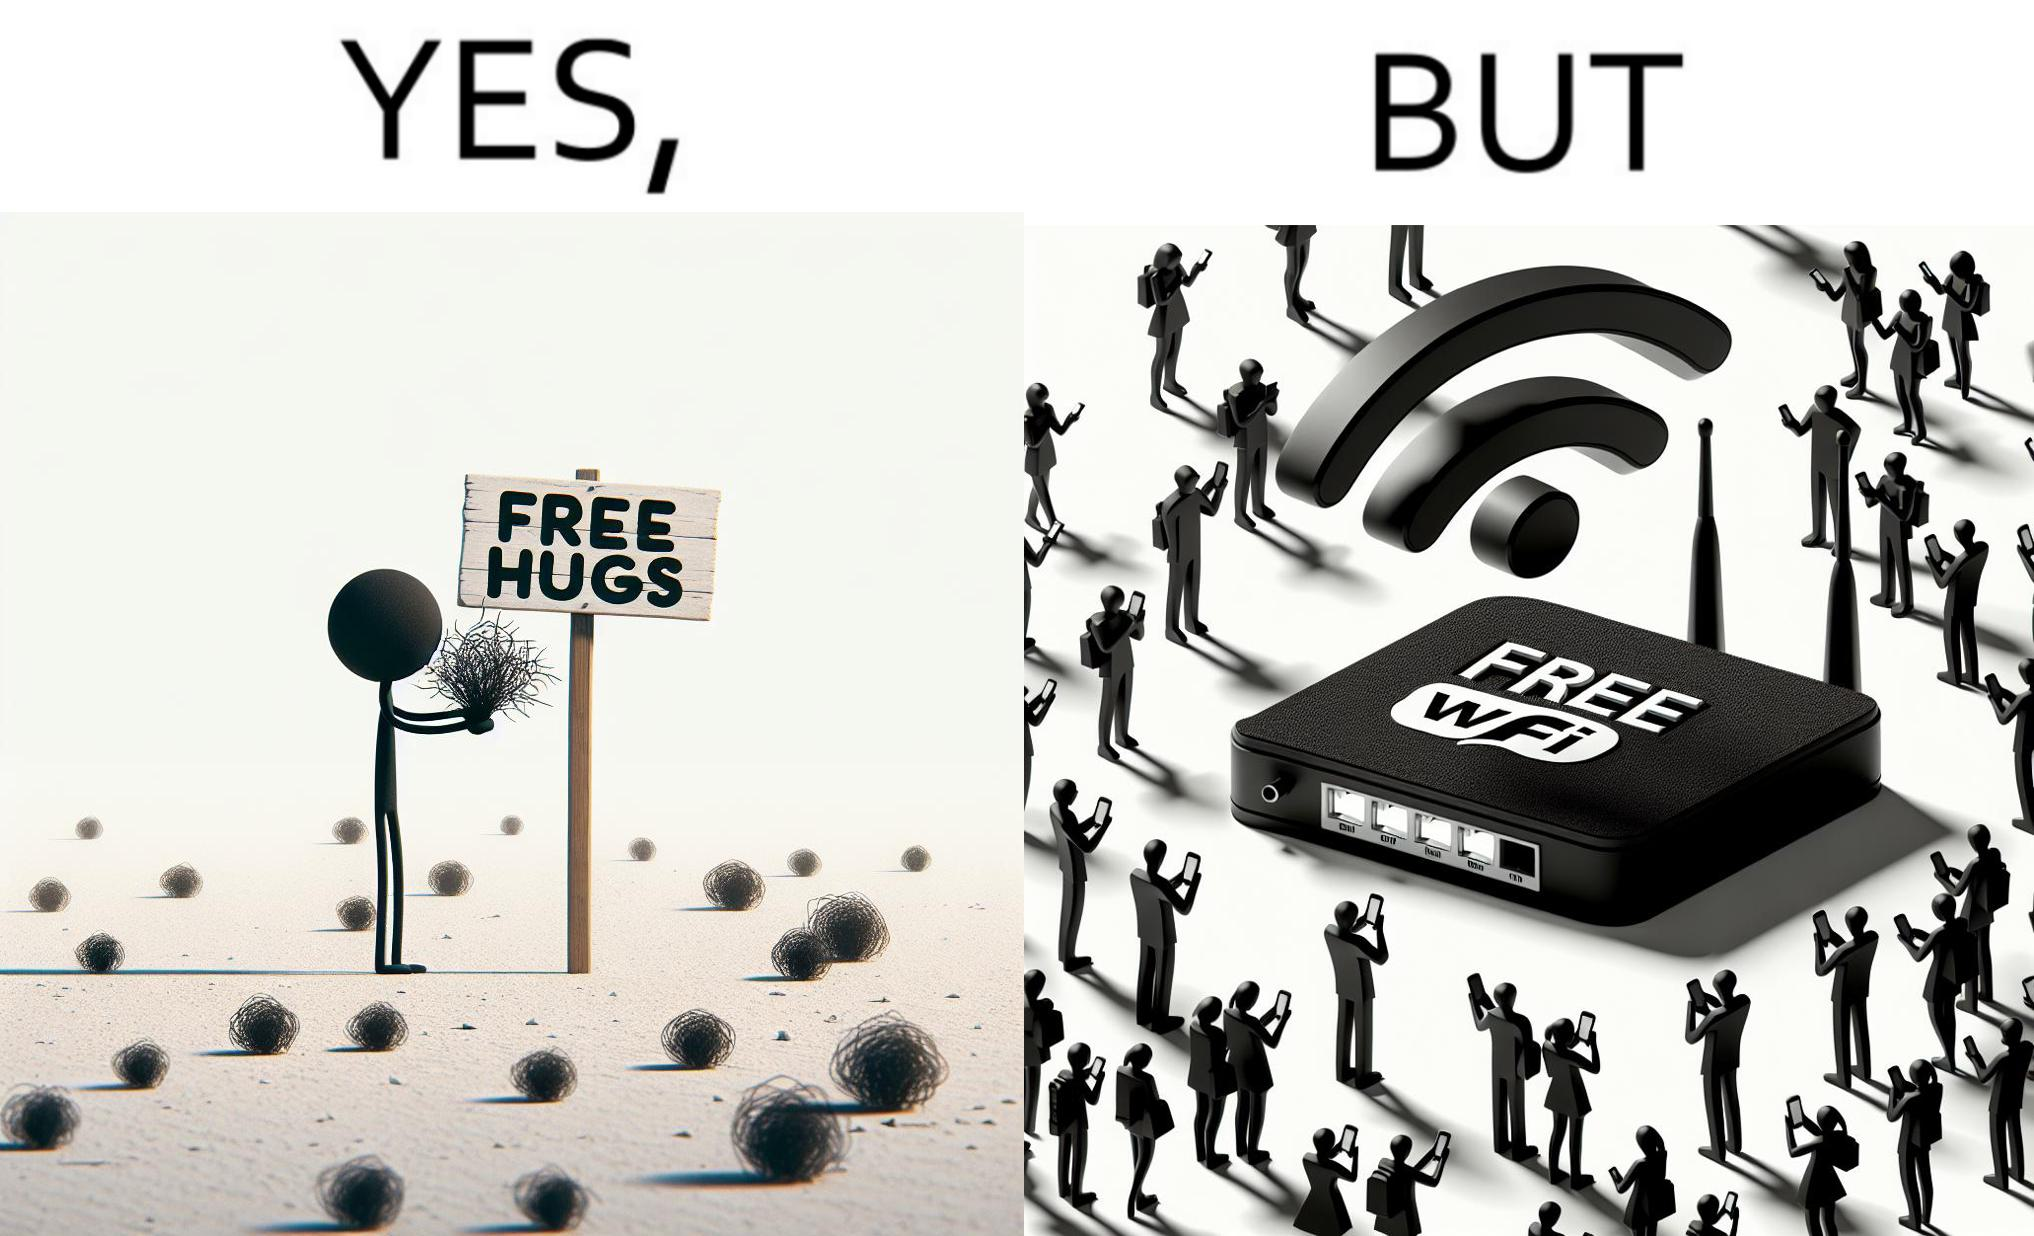Describe what you see in this image. This image is ironical, as a person holding up a "Free Hugs" sign is standing alone, while an inanimate Wi-fi Router giving "Free Wifi" is surrounded people trying to connect to it. This shows a growing lack of empathy in our society, while showing our increasing dependence on the digital devices in a virtual world. 